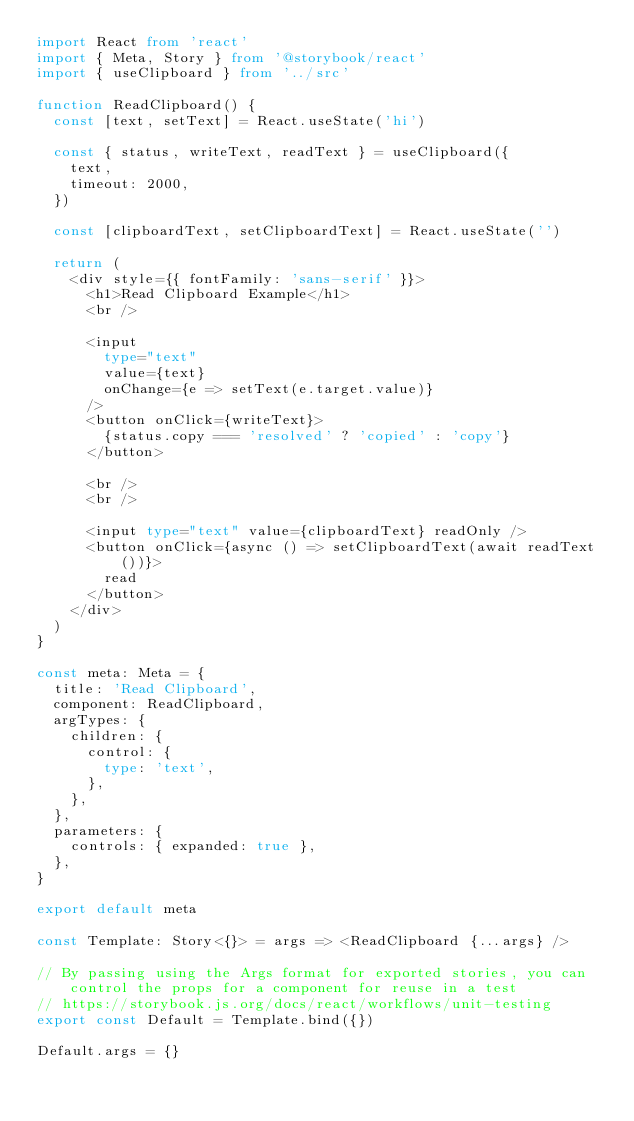Convert code to text. <code><loc_0><loc_0><loc_500><loc_500><_TypeScript_>import React from 'react'
import { Meta, Story } from '@storybook/react'
import { useClipboard } from '../src'

function ReadClipboard() {
  const [text, setText] = React.useState('hi')

  const { status, writeText, readText } = useClipboard({
    text,
    timeout: 2000,
  })

  const [clipboardText, setClipboardText] = React.useState('')

  return (
    <div style={{ fontFamily: 'sans-serif' }}>
      <h1>Read Clipboard Example</h1>
      <br />

      <input
        type="text"
        value={text}
        onChange={e => setText(e.target.value)}
      />
      <button onClick={writeText}>
        {status.copy === 'resolved' ? 'copied' : 'copy'}
      </button>

      <br />
      <br />

      <input type="text" value={clipboardText} readOnly />
      <button onClick={async () => setClipboardText(await readText())}>
        read
      </button>
    </div>
  )
}

const meta: Meta = {
  title: 'Read Clipboard',
  component: ReadClipboard,
  argTypes: {
    children: {
      control: {
        type: 'text',
      },
    },
  },
  parameters: {
    controls: { expanded: true },
  },
}

export default meta

const Template: Story<{}> = args => <ReadClipboard {...args} />

// By passing using the Args format for exported stories, you can control the props for a component for reuse in a test
// https://storybook.js.org/docs/react/workflows/unit-testing
export const Default = Template.bind({})

Default.args = {}
</code> 